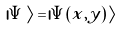Convert formula to latex. <formula><loc_0><loc_0><loc_500><loc_500>| \Psi \, \rangle = \, | \Psi ( x , y ) \, \rangle</formula> 